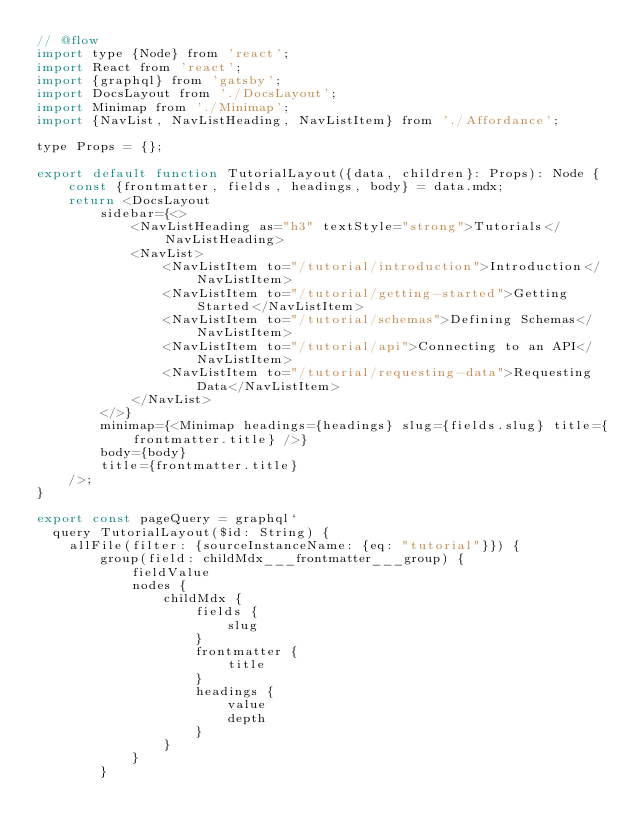Convert code to text. <code><loc_0><loc_0><loc_500><loc_500><_JavaScript_>// @flow
import type {Node} from 'react';
import React from 'react';
import {graphql} from 'gatsby';
import DocsLayout from './DocsLayout';
import Minimap from './Minimap';
import {NavList, NavListHeading, NavListItem} from './Affordance';

type Props = {};

export default function TutorialLayout({data, children}: Props): Node {
    const {frontmatter, fields, headings, body} = data.mdx;
    return <DocsLayout
        sidebar={<>
            <NavListHeading as="h3" textStyle="strong">Tutorials</NavListHeading>
            <NavList>
                <NavListItem to="/tutorial/introduction">Introduction</NavListItem>
                <NavListItem to="/tutorial/getting-started">Getting Started</NavListItem>
                <NavListItem to="/tutorial/schemas">Defining Schemas</NavListItem>
                <NavListItem to="/tutorial/api">Connecting to an API</NavListItem>
                <NavListItem to="/tutorial/requesting-data">Requesting Data</NavListItem>
            </NavList>
        </>}
        minimap={<Minimap headings={headings} slug={fields.slug} title={frontmatter.title} />}
        body={body}
        title={frontmatter.title}
    />;
}

export const pageQuery = graphql`
  query TutorialLayout($id: String) {
    allFile(filter: {sourceInstanceName: {eq: "tutorial"}}) {
        group(field: childMdx___frontmatter___group) {
            fieldValue
            nodes {
                childMdx {
                    fields {
                        slug
                    }
                    frontmatter {
                        title
                    }
                    headings {
                        value
                        depth
                    }
                }
            }
        }</code> 